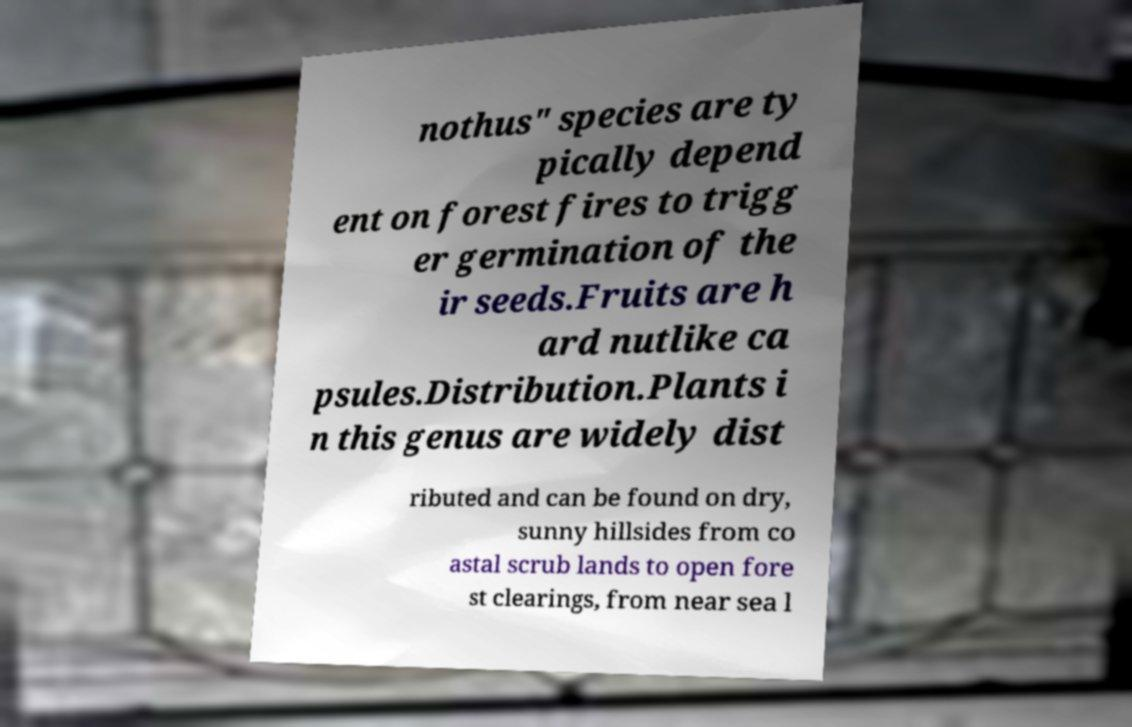Could you assist in decoding the text presented in this image and type it out clearly? nothus" species are ty pically depend ent on forest fires to trigg er germination of the ir seeds.Fruits are h ard nutlike ca psules.Distribution.Plants i n this genus are widely dist ributed and can be found on dry, sunny hillsides from co astal scrub lands to open fore st clearings, from near sea l 